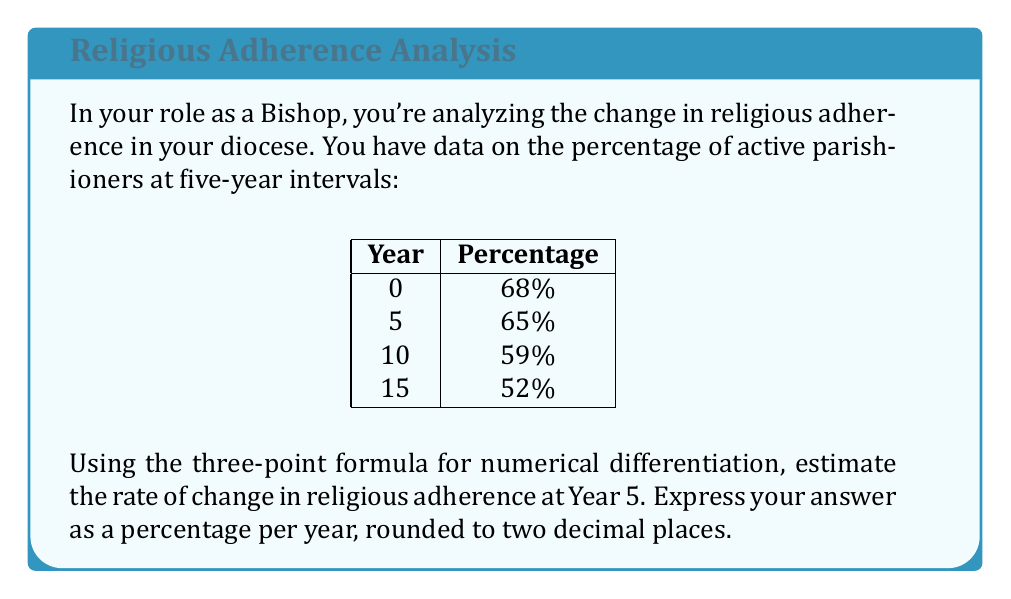Could you help me with this problem? To solve this problem, we'll use the three-point formula for numerical differentiation:

$$f'(x) \approx \frac{f(x+h) - f(x-h)}{2h}$$

Where:
$f(x)$ is the function we're differentiating (percentage of adherence)
$x$ is the point at which we're estimating the derivative (Year 5)
$h$ is the step size (5 years)

Step 1: Identify the relevant data points:
$f(x-h) = f(0) = 68\%$
$f(x) = f(5) = 65\%$
$f(x+h) = f(10) = 59\%$

Step 2: Apply the three-point formula:

$$f'(5) \approx \frac{f(10) - f(0)}{2(5)}$$

$$f'(5) \approx \frac{59\% - 68\%}{10}$$

$$f'(5) \approx \frac{-9\%}{10}$$

$$f'(5) \approx -0.9\% \text{ per year}$$

Step 3: Round to two decimal places:
$-0.90\%$ per year

This negative value indicates a decline in religious adherence of approximately 0.90% per year at Year 5.
Answer: $-0.90\%$ per year 